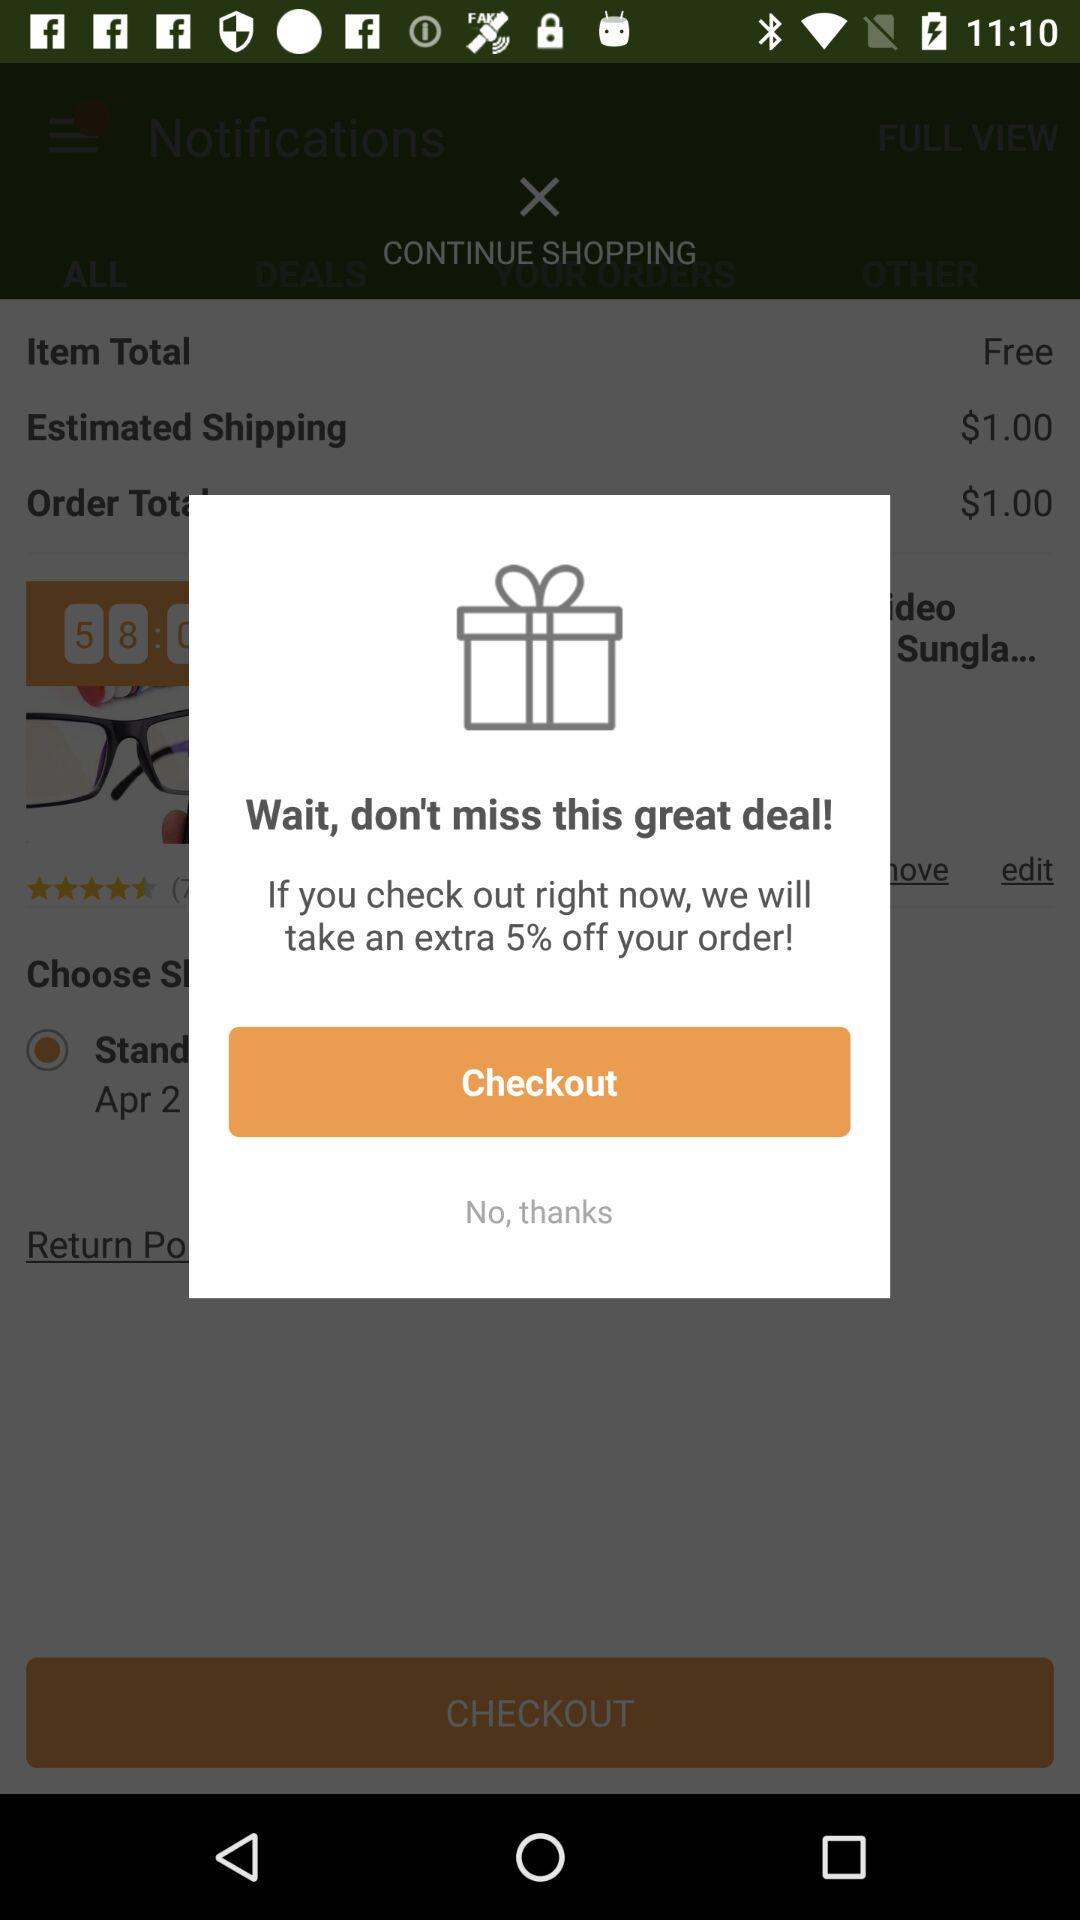How many percent off is being offered?
Answer the question using a single word or phrase. 5% 